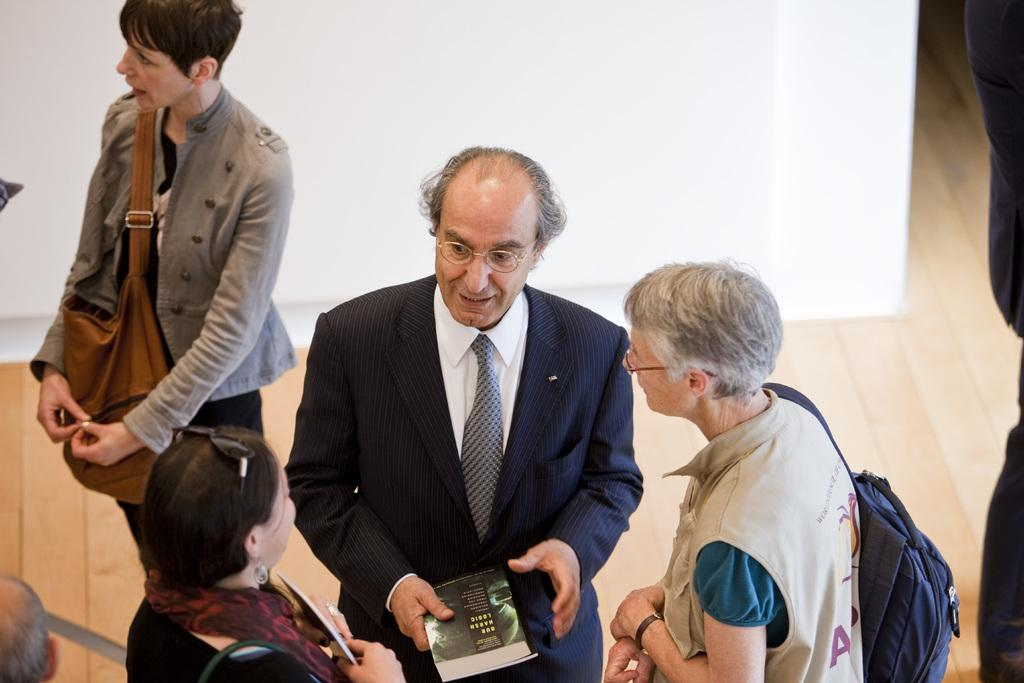What is the person in the image wearing? The person is wearing a suit, shirt, and tie in the image. What is the person holding in the image? The person is holding a book. How many women are in the image? There are two women in the image. What are the women doing in the image? The women are listening to the person. What color is the wall in the background of the image? The wall in the background of the image is white. Can you see a banana in the image? No, there is no banana present in the image. Is the person in the image a spy? There is no information in the image to suggest that the person is a spy. 